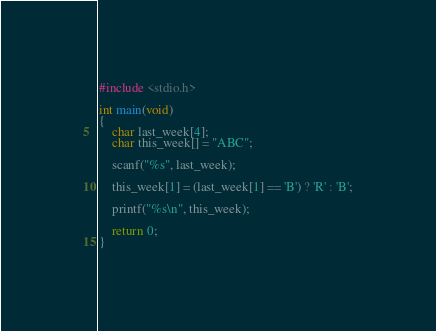<code> <loc_0><loc_0><loc_500><loc_500><_C_>#include <stdio.h>

int main(void)
{
	char last_week[4];
	char this_week[] = "ABC";

	scanf("%s", last_week);

	this_week[1] = (last_week[1] == 'B') ? 'R' : 'B';

	printf("%s\n", this_week);

	return 0;
}</code> 